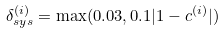<formula> <loc_0><loc_0><loc_500><loc_500>\delta ^ { ( i ) } _ { s y s } = \max ( 0 . 0 3 , 0 . 1 | 1 - c ^ { ( i ) } | )</formula> 